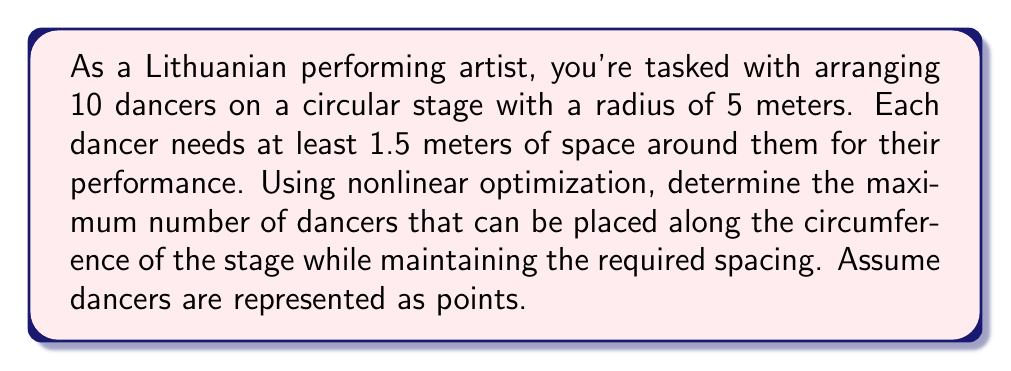Solve this math problem. Let's approach this step-by-step using nonlinear optimization:

1) First, we need to define our objective function and constraints:
   - Objective: Maximize the number of dancers (n)
   - Constraint: Maintain minimum distance between dancers

2) The circumference of the stage is:
   $$C = 2\pi r = 2\pi(5) = 10\pi \approx 31.4159 \text{ meters}$$

3) If we place n dancers equally spaced around the circumference, the arc length between each dancer is:
   $$\text{Arc length} = \frac{C}{n} = \frac{10\pi}{n}$$

4) We can convert this arc length to a straight-line distance using the chord length formula:
   $$\text{Chord length} = 2r \sin(\frac{\theta}{2}) = 10 \sin(\frac{\pi}{n})$$

5) Our constraint is that this chord length must be at least 1.5 meters:
   $$10 \sin(\frac{\pi}{n}) \geq 1.5$$

6) Solving this inequality:
   $$\sin(\frac{\pi}{n}) \geq 0.15$$
   $$\frac{\pi}{n} \geq \arcsin(0.15)$$
   $$n \leq \frac{\pi}{\arcsin(0.15)} \approx 20.8$$

7) Since n must be an integer, the maximum number of dancers is the floor of this value:
   $$n = \lfloor\frac{\pi}{\arcsin(0.15)}\rfloor = 20$$

Therefore, the maximum number of dancers that can be arranged on the stage while maintaining the required spacing is 20.
Answer: 20 dancers 